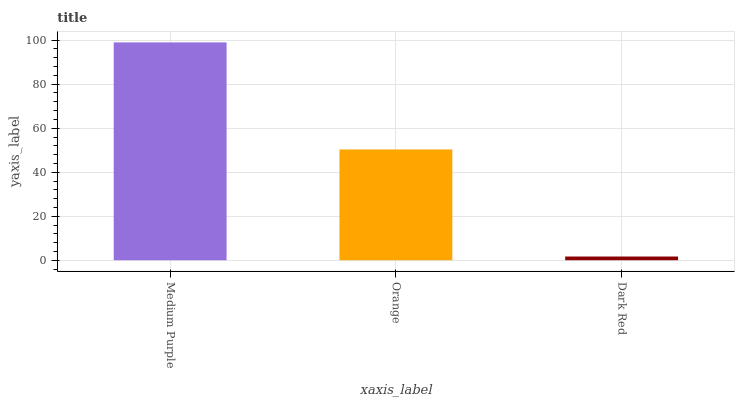Is Orange the minimum?
Answer yes or no. No. Is Orange the maximum?
Answer yes or no. No. Is Medium Purple greater than Orange?
Answer yes or no. Yes. Is Orange less than Medium Purple?
Answer yes or no. Yes. Is Orange greater than Medium Purple?
Answer yes or no. No. Is Medium Purple less than Orange?
Answer yes or no. No. Is Orange the high median?
Answer yes or no. Yes. Is Orange the low median?
Answer yes or no. Yes. Is Dark Red the high median?
Answer yes or no. No. Is Dark Red the low median?
Answer yes or no. No. 